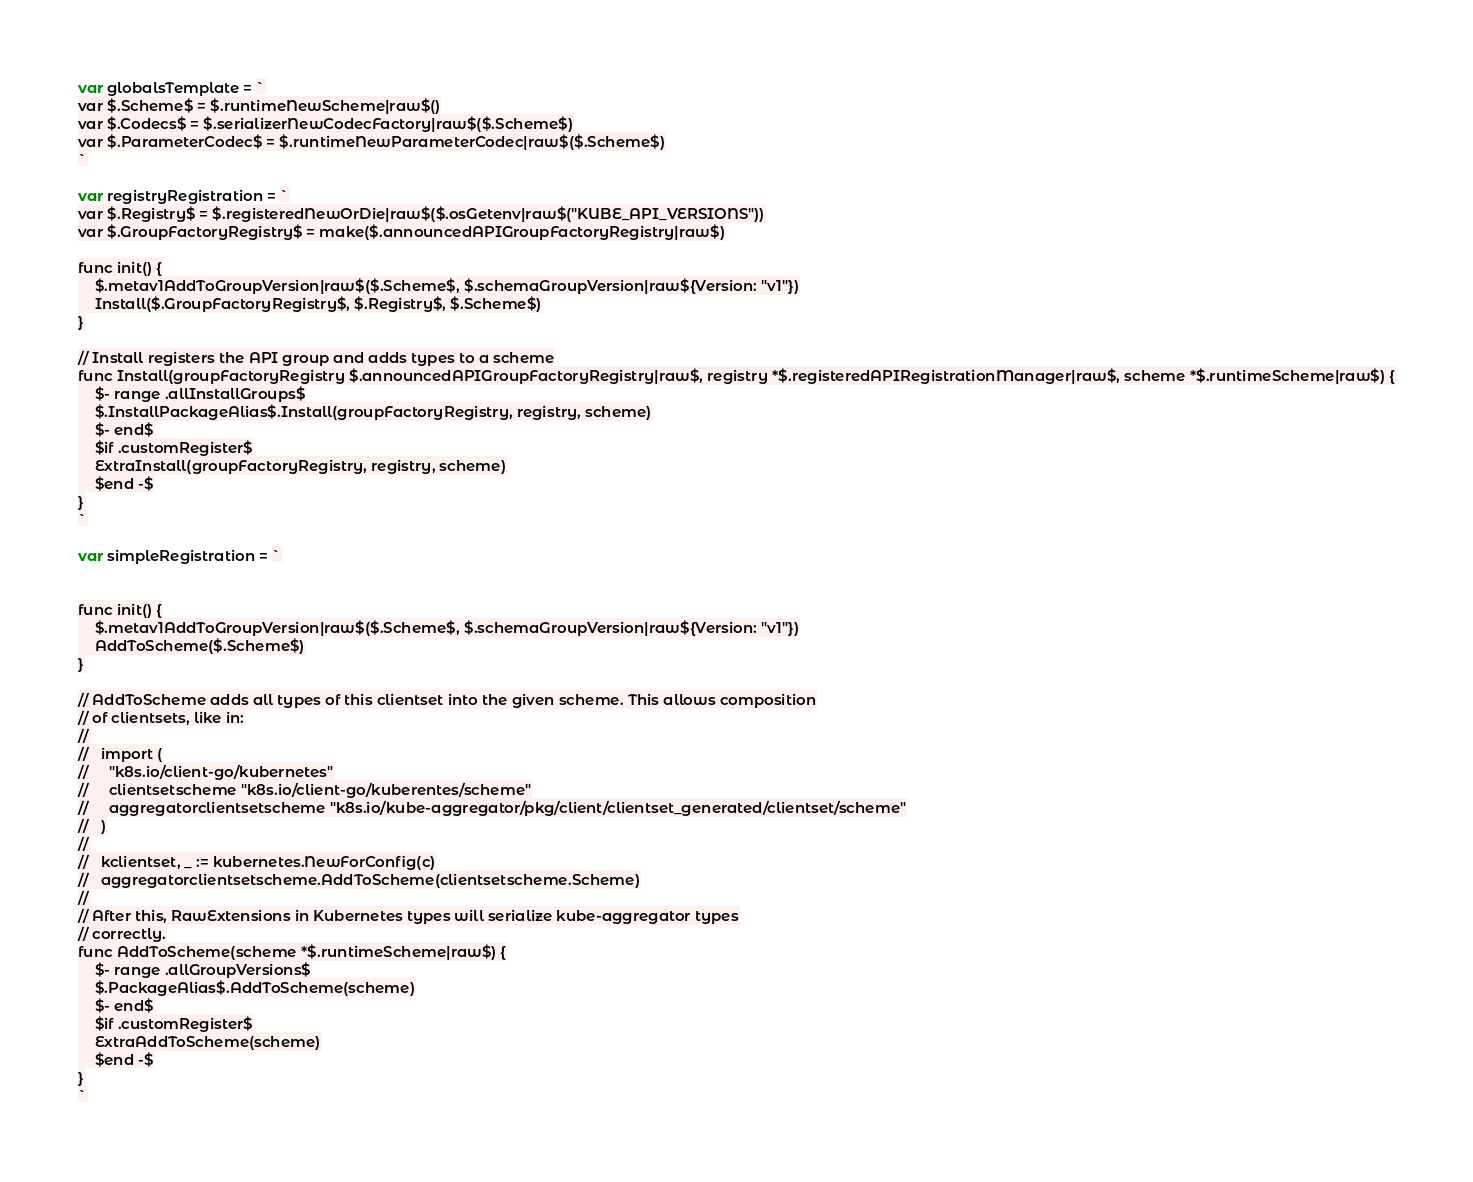<code> <loc_0><loc_0><loc_500><loc_500><_Go_>
var globalsTemplate = `
var $.Scheme$ = $.runtimeNewScheme|raw$()
var $.Codecs$ = $.serializerNewCodecFactory|raw$($.Scheme$)
var $.ParameterCodec$ = $.runtimeNewParameterCodec|raw$($.Scheme$)
`

var registryRegistration = `
var $.Registry$ = $.registeredNewOrDie|raw$($.osGetenv|raw$("KUBE_API_VERSIONS"))
var $.GroupFactoryRegistry$ = make($.announcedAPIGroupFactoryRegistry|raw$)

func init() {
	$.metav1AddToGroupVersion|raw$($.Scheme$, $.schemaGroupVersion|raw${Version: "v1"})
	Install($.GroupFactoryRegistry$, $.Registry$, $.Scheme$)
}

// Install registers the API group and adds types to a scheme
func Install(groupFactoryRegistry $.announcedAPIGroupFactoryRegistry|raw$, registry *$.registeredAPIRegistrationManager|raw$, scheme *$.runtimeScheme|raw$) {
	$- range .allInstallGroups$
	$.InstallPackageAlias$.Install(groupFactoryRegistry, registry, scheme)
	$- end$
	$if .customRegister$
	ExtraInstall(groupFactoryRegistry, registry, scheme)
	$end -$
}
`

var simpleRegistration = `


func init() {
	$.metav1AddToGroupVersion|raw$($.Scheme$, $.schemaGroupVersion|raw${Version: "v1"})
	AddToScheme($.Scheme$)
}

// AddToScheme adds all types of this clientset into the given scheme. This allows composition
// of clientsets, like in:
//
//   import (
//     "k8s.io/client-go/kubernetes"
//     clientsetscheme "k8s.io/client-go/kuberentes/scheme"
//     aggregatorclientsetscheme "k8s.io/kube-aggregator/pkg/client/clientset_generated/clientset/scheme"
//   )
//
//   kclientset, _ := kubernetes.NewForConfig(c)
//   aggregatorclientsetscheme.AddToScheme(clientsetscheme.Scheme)
//
// After this, RawExtensions in Kubernetes types will serialize kube-aggregator types
// correctly.
func AddToScheme(scheme *$.runtimeScheme|raw$) {
	$- range .allGroupVersions$
	$.PackageAlias$.AddToScheme(scheme)
	$- end$
	$if .customRegister$
	ExtraAddToScheme(scheme)
	$end -$
}
`
</code> 